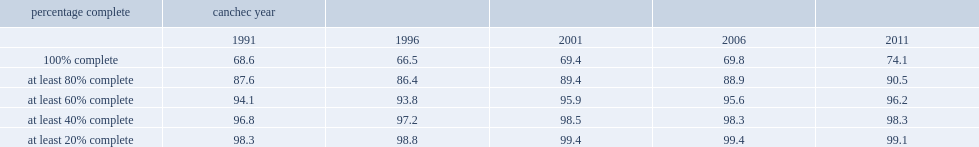What's the percentage of canchec cohort members aged 20 or older who had complete postal code histories in 2011? 74.1. 